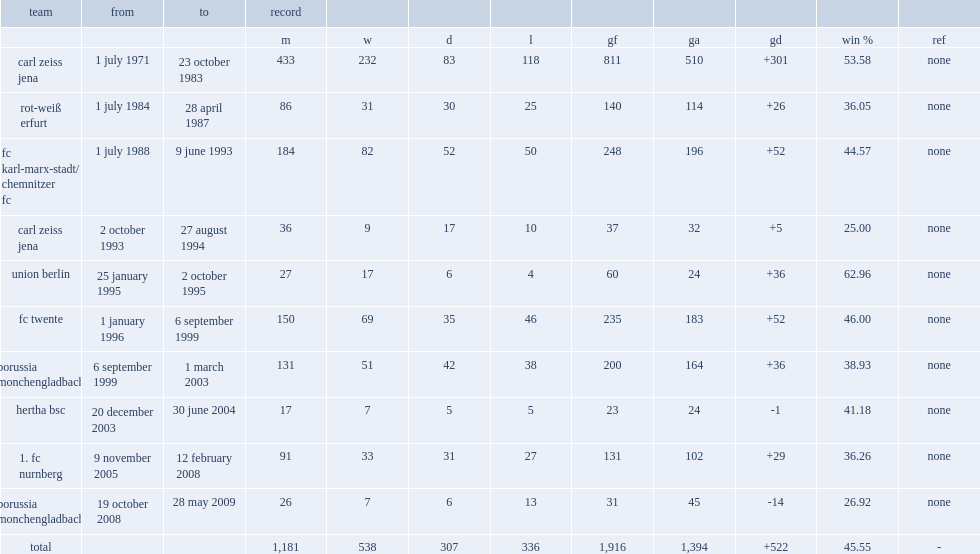Which team employed meyer from january 25, 1995 to october 2, 1995 as its manager. Union berlin. 